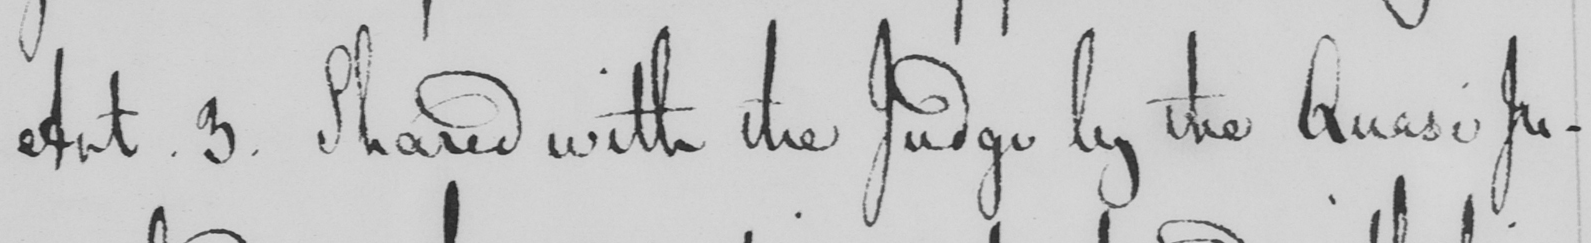Can you tell me what this handwritten text says? Art . 3 . Shared with the Judge by the Quasi Ju- 